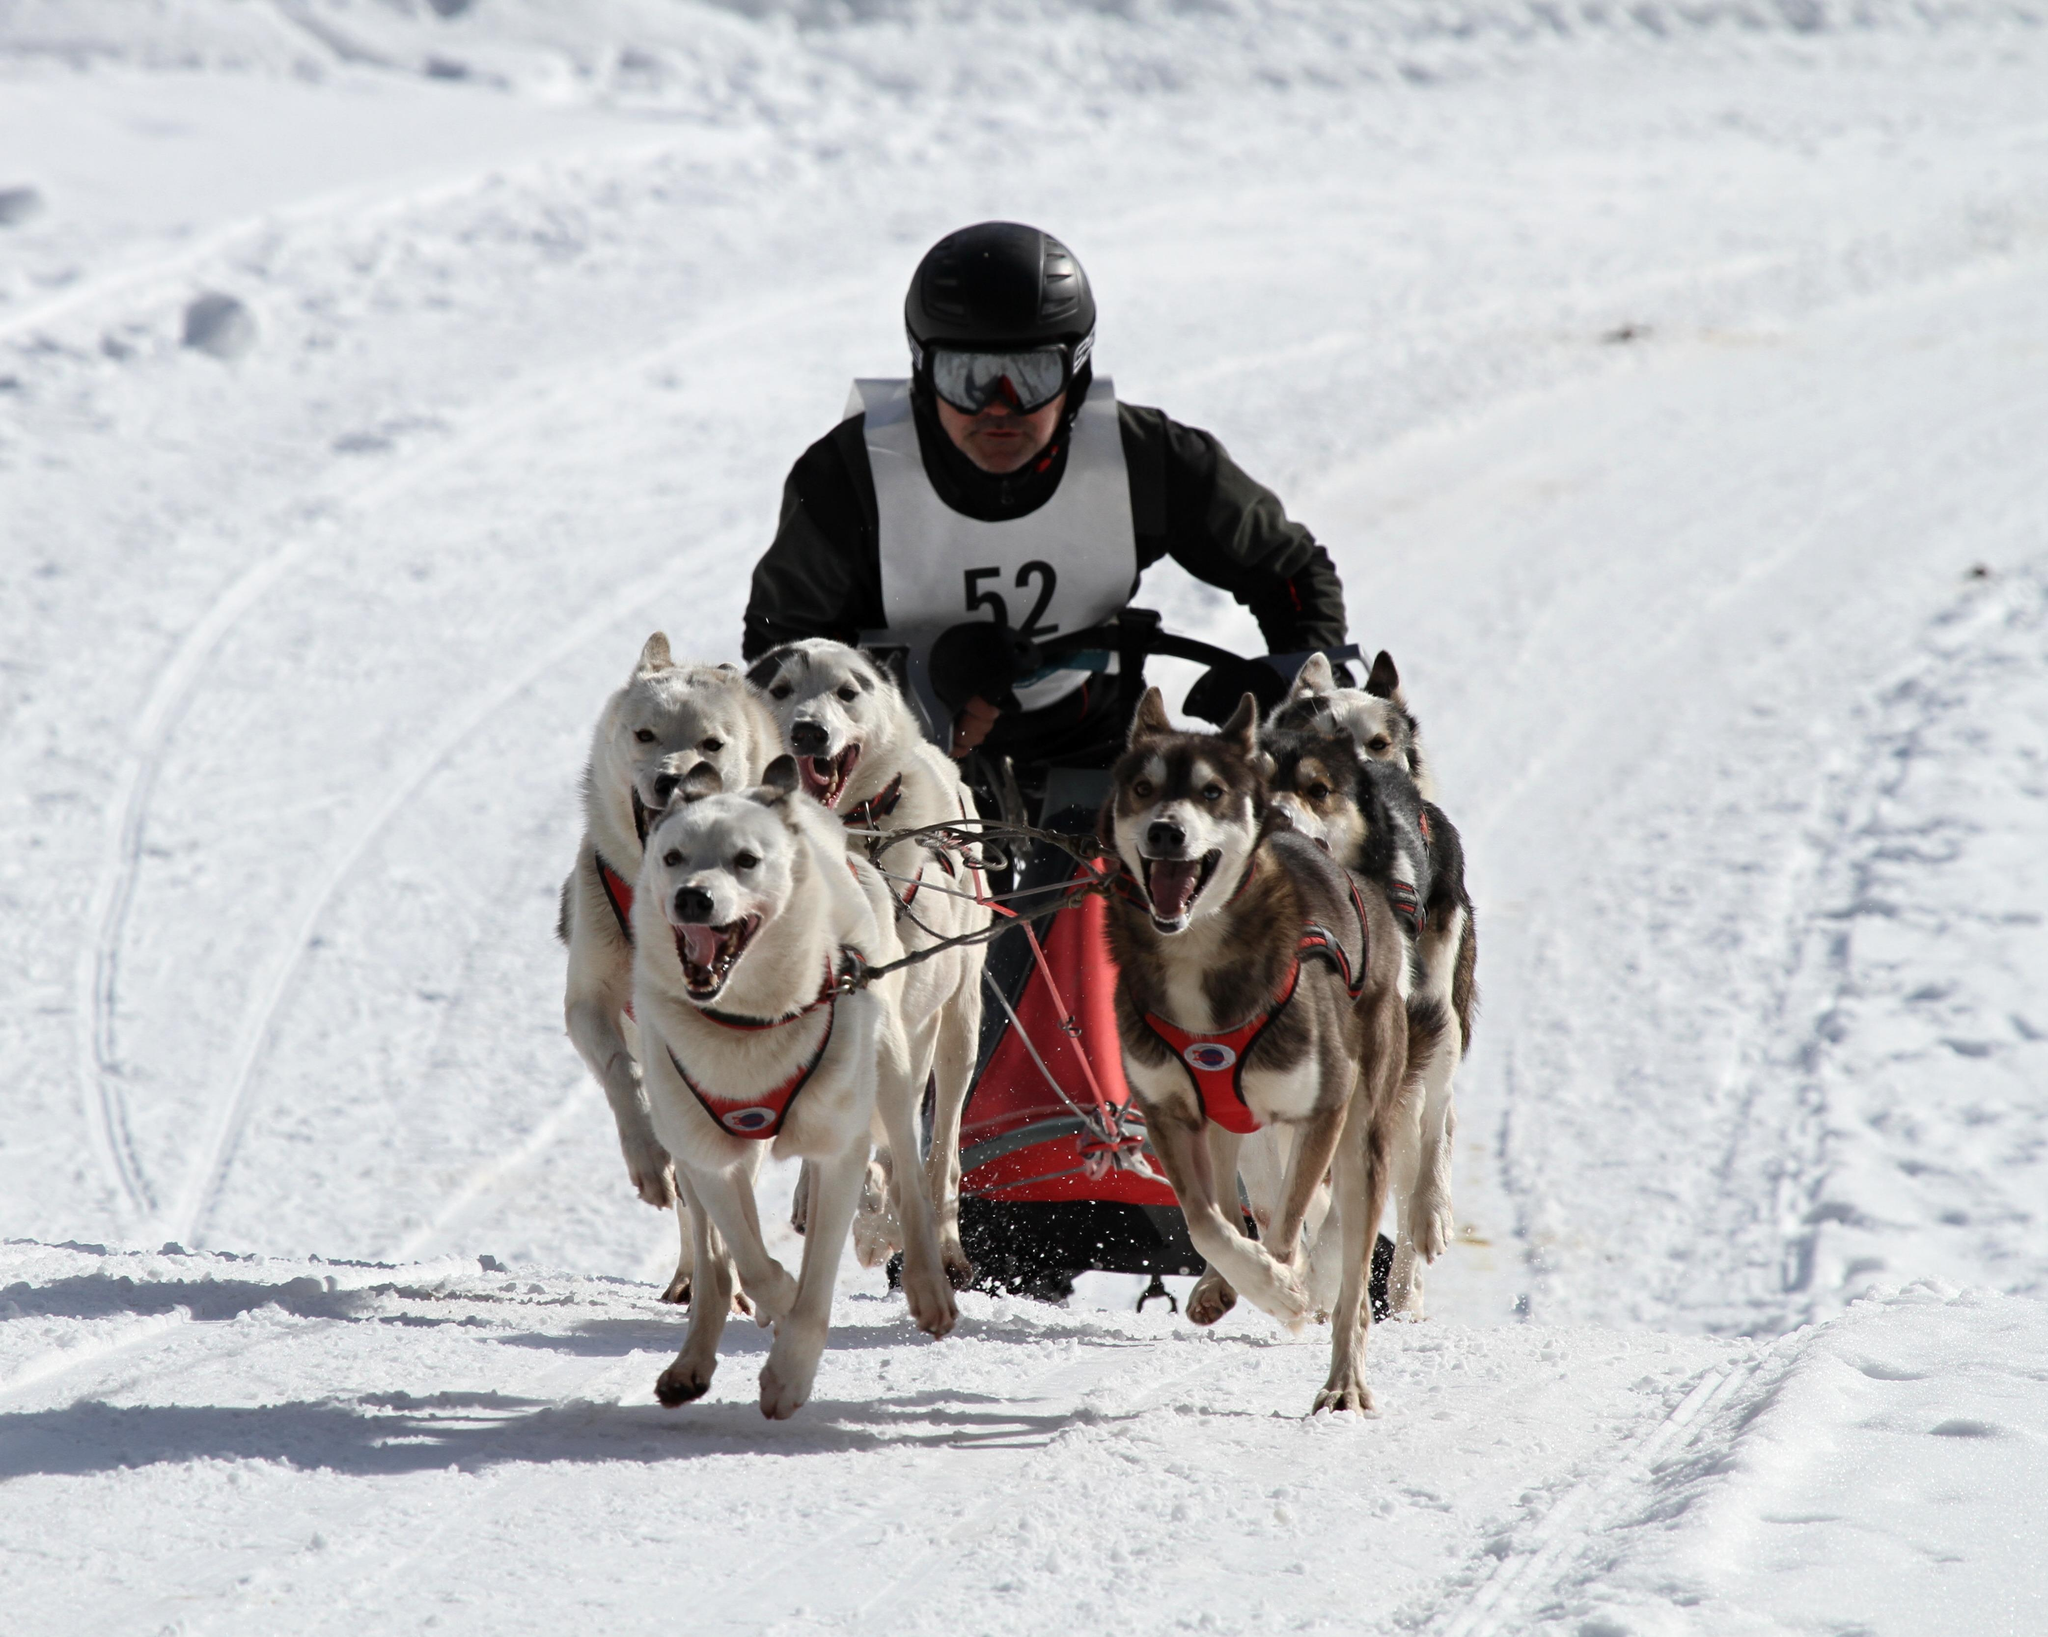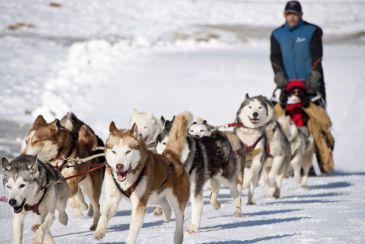The first image is the image on the left, the second image is the image on the right. Analyze the images presented: Is the assertion "A person wearing a blue jacket is driving the sled." valid? Answer yes or no. Yes. 